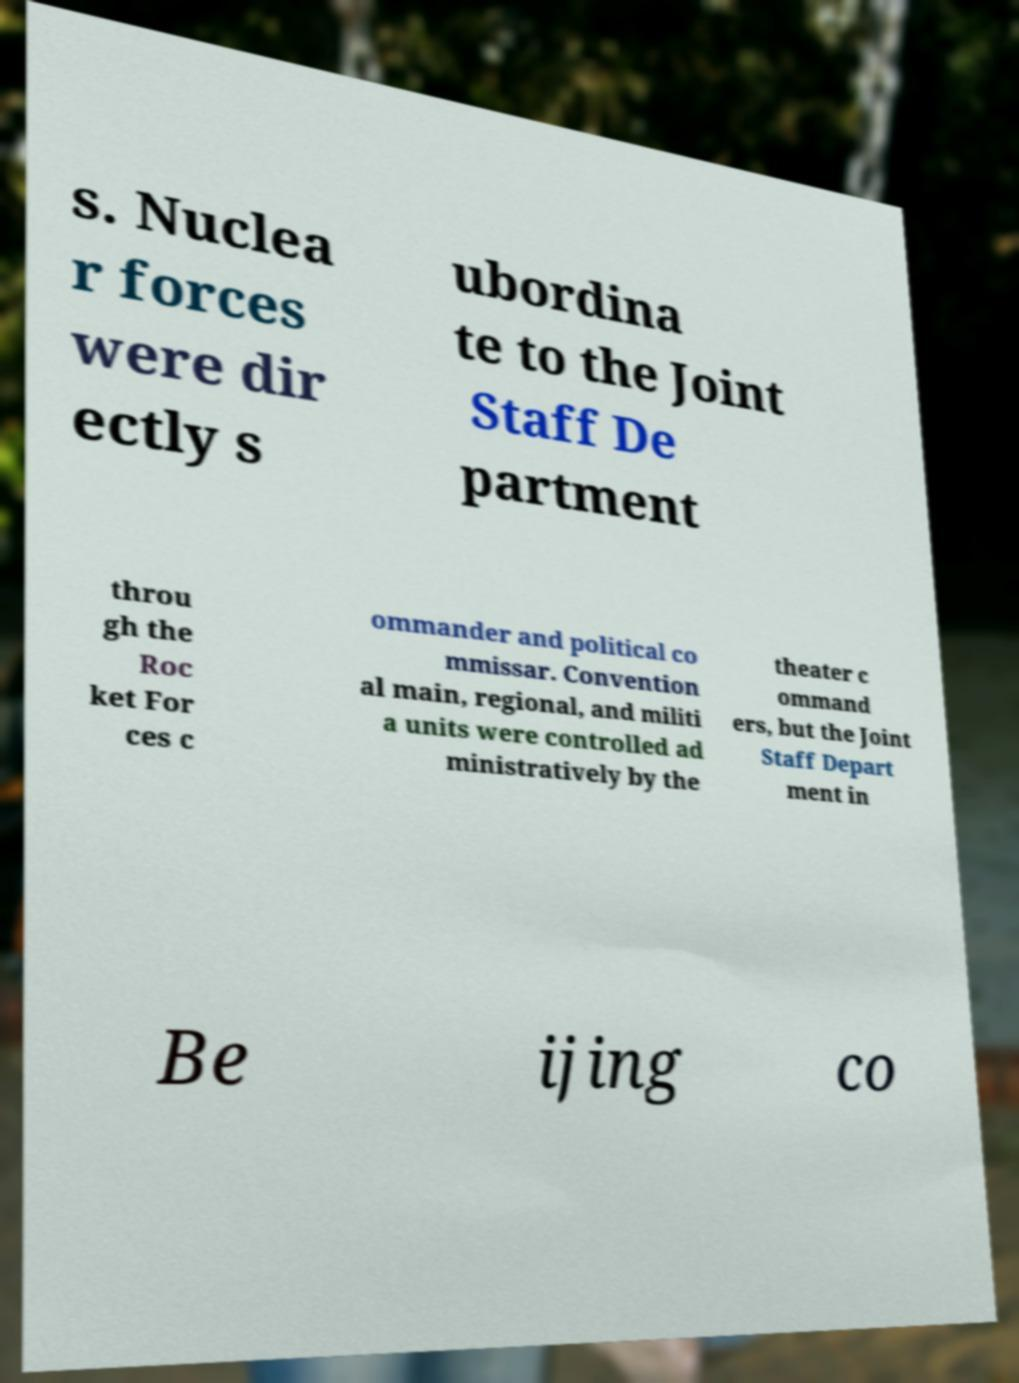I need the written content from this picture converted into text. Can you do that? s. Nuclea r forces were dir ectly s ubordina te to the Joint Staff De partment throu gh the Roc ket For ces c ommander and political co mmissar. Convention al main, regional, and militi a units were controlled ad ministratively by the theater c ommand ers, but the Joint Staff Depart ment in Be ijing co 